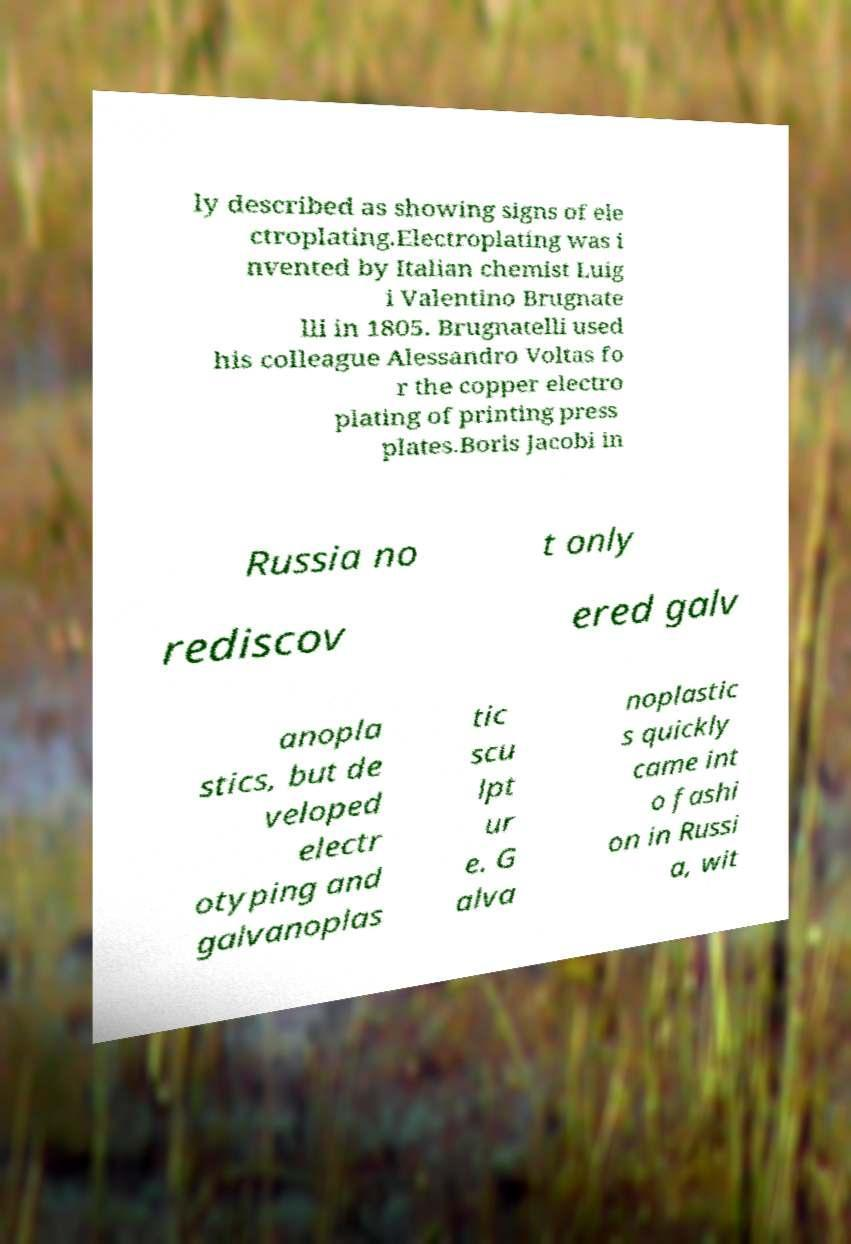Please read and relay the text visible in this image. What does it say? ly described as showing signs of ele ctroplating.Electroplating was i nvented by Italian chemist Luig i Valentino Brugnate lli in 1805. Brugnatelli used his colleague Alessandro Voltas fo r the copper electro plating of printing press plates.Boris Jacobi in Russia no t only rediscov ered galv anopla stics, but de veloped electr otyping and galvanoplas tic scu lpt ur e. G alva noplastic s quickly came int o fashi on in Russi a, wit 